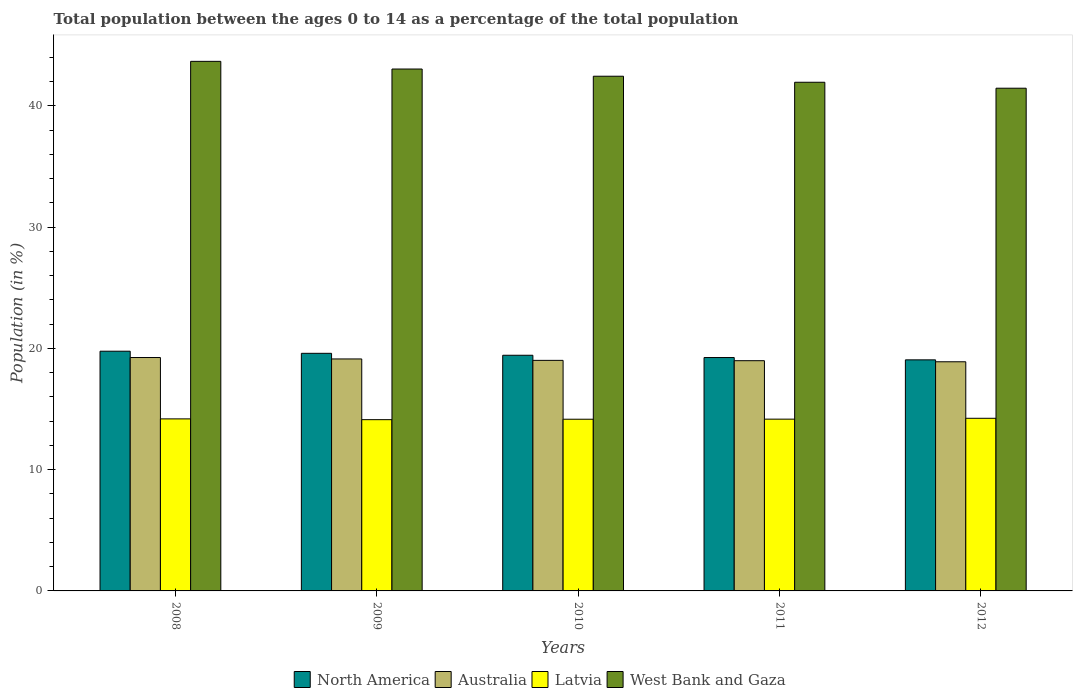How many different coloured bars are there?
Keep it short and to the point. 4. How many groups of bars are there?
Your response must be concise. 5. Are the number of bars per tick equal to the number of legend labels?
Your answer should be compact. Yes. How many bars are there on the 3rd tick from the left?
Give a very brief answer. 4. What is the percentage of the population ages 0 to 14 in Australia in 2012?
Your answer should be compact. 18.89. Across all years, what is the maximum percentage of the population ages 0 to 14 in Latvia?
Give a very brief answer. 14.23. Across all years, what is the minimum percentage of the population ages 0 to 14 in Australia?
Provide a succinct answer. 18.89. In which year was the percentage of the population ages 0 to 14 in North America maximum?
Keep it short and to the point. 2008. In which year was the percentage of the population ages 0 to 14 in Australia minimum?
Keep it short and to the point. 2012. What is the total percentage of the population ages 0 to 14 in Australia in the graph?
Offer a terse response. 95.25. What is the difference between the percentage of the population ages 0 to 14 in Latvia in 2009 and that in 2011?
Offer a terse response. -0.04. What is the difference between the percentage of the population ages 0 to 14 in West Bank and Gaza in 2008 and the percentage of the population ages 0 to 14 in North America in 2009?
Your answer should be compact. 24.07. What is the average percentage of the population ages 0 to 14 in North America per year?
Give a very brief answer. 19.41. In the year 2009, what is the difference between the percentage of the population ages 0 to 14 in North America and percentage of the population ages 0 to 14 in Australia?
Keep it short and to the point. 0.46. What is the ratio of the percentage of the population ages 0 to 14 in North America in 2009 to that in 2012?
Your response must be concise. 1.03. Is the percentage of the population ages 0 to 14 in Australia in 2010 less than that in 2011?
Make the answer very short. No. Is the difference between the percentage of the population ages 0 to 14 in North America in 2011 and 2012 greater than the difference between the percentage of the population ages 0 to 14 in Australia in 2011 and 2012?
Provide a short and direct response. Yes. What is the difference between the highest and the second highest percentage of the population ages 0 to 14 in West Bank and Gaza?
Provide a succinct answer. 0.63. What is the difference between the highest and the lowest percentage of the population ages 0 to 14 in Latvia?
Your answer should be compact. 0.11. Is the sum of the percentage of the population ages 0 to 14 in Latvia in 2011 and 2012 greater than the maximum percentage of the population ages 0 to 14 in West Bank and Gaza across all years?
Provide a short and direct response. No. What does the 4th bar from the left in 2010 represents?
Your answer should be very brief. West Bank and Gaza. What does the 4th bar from the right in 2011 represents?
Offer a very short reply. North America. Is it the case that in every year, the sum of the percentage of the population ages 0 to 14 in Australia and percentage of the population ages 0 to 14 in Latvia is greater than the percentage of the population ages 0 to 14 in West Bank and Gaza?
Offer a terse response. No. How many years are there in the graph?
Offer a very short reply. 5. Where does the legend appear in the graph?
Your answer should be very brief. Bottom center. How many legend labels are there?
Provide a short and direct response. 4. How are the legend labels stacked?
Your response must be concise. Horizontal. What is the title of the graph?
Your answer should be compact. Total population between the ages 0 to 14 as a percentage of the total population. Does "China" appear as one of the legend labels in the graph?
Your answer should be very brief. No. What is the label or title of the X-axis?
Your response must be concise. Years. What is the Population (in %) in North America in 2008?
Your answer should be very brief. 19.76. What is the Population (in %) of Australia in 2008?
Give a very brief answer. 19.24. What is the Population (in %) of Latvia in 2008?
Your response must be concise. 14.18. What is the Population (in %) of West Bank and Gaza in 2008?
Make the answer very short. 43.66. What is the Population (in %) of North America in 2009?
Provide a short and direct response. 19.59. What is the Population (in %) of Australia in 2009?
Give a very brief answer. 19.13. What is the Population (in %) in Latvia in 2009?
Offer a terse response. 14.12. What is the Population (in %) of West Bank and Gaza in 2009?
Make the answer very short. 43.03. What is the Population (in %) of North America in 2010?
Ensure brevity in your answer.  19.43. What is the Population (in %) of Australia in 2010?
Make the answer very short. 19.01. What is the Population (in %) in Latvia in 2010?
Your answer should be compact. 14.15. What is the Population (in %) in West Bank and Gaza in 2010?
Make the answer very short. 42.43. What is the Population (in %) in North America in 2011?
Provide a succinct answer. 19.24. What is the Population (in %) of Australia in 2011?
Your answer should be compact. 18.98. What is the Population (in %) of Latvia in 2011?
Your answer should be compact. 14.16. What is the Population (in %) of West Bank and Gaza in 2011?
Offer a terse response. 41.94. What is the Population (in %) in North America in 2012?
Provide a short and direct response. 19.05. What is the Population (in %) of Australia in 2012?
Ensure brevity in your answer.  18.89. What is the Population (in %) of Latvia in 2012?
Offer a terse response. 14.23. What is the Population (in %) of West Bank and Gaza in 2012?
Ensure brevity in your answer.  41.45. Across all years, what is the maximum Population (in %) in North America?
Offer a very short reply. 19.76. Across all years, what is the maximum Population (in %) in Australia?
Give a very brief answer. 19.24. Across all years, what is the maximum Population (in %) in Latvia?
Keep it short and to the point. 14.23. Across all years, what is the maximum Population (in %) of West Bank and Gaza?
Your answer should be very brief. 43.66. Across all years, what is the minimum Population (in %) in North America?
Your response must be concise. 19.05. Across all years, what is the minimum Population (in %) in Australia?
Offer a very short reply. 18.89. Across all years, what is the minimum Population (in %) of Latvia?
Provide a succinct answer. 14.12. Across all years, what is the minimum Population (in %) in West Bank and Gaza?
Offer a terse response. 41.45. What is the total Population (in %) of North America in the graph?
Make the answer very short. 97.07. What is the total Population (in %) of Australia in the graph?
Your answer should be compact. 95.25. What is the total Population (in %) in Latvia in the graph?
Offer a very short reply. 70.85. What is the total Population (in %) of West Bank and Gaza in the graph?
Your response must be concise. 212.5. What is the difference between the Population (in %) of North America in 2008 and that in 2009?
Your response must be concise. 0.17. What is the difference between the Population (in %) in Australia in 2008 and that in 2009?
Offer a very short reply. 0.12. What is the difference between the Population (in %) in Latvia in 2008 and that in 2009?
Your response must be concise. 0.06. What is the difference between the Population (in %) in West Bank and Gaza in 2008 and that in 2009?
Your answer should be compact. 0.63. What is the difference between the Population (in %) in North America in 2008 and that in 2010?
Offer a terse response. 0.33. What is the difference between the Population (in %) of Australia in 2008 and that in 2010?
Provide a short and direct response. 0.23. What is the difference between the Population (in %) of Latvia in 2008 and that in 2010?
Offer a very short reply. 0.03. What is the difference between the Population (in %) of West Bank and Gaza in 2008 and that in 2010?
Make the answer very short. 1.23. What is the difference between the Population (in %) in North America in 2008 and that in 2011?
Keep it short and to the point. 0.52. What is the difference between the Population (in %) of Australia in 2008 and that in 2011?
Keep it short and to the point. 0.26. What is the difference between the Population (in %) in Latvia in 2008 and that in 2011?
Keep it short and to the point. 0.02. What is the difference between the Population (in %) of West Bank and Gaza in 2008 and that in 2011?
Provide a short and direct response. 1.72. What is the difference between the Population (in %) in North America in 2008 and that in 2012?
Ensure brevity in your answer.  0.71. What is the difference between the Population (in %) of Australia in 2008 and that in 2012?
Keep it short and to the point. 0.35. What is the difference between the Population (in %) in Latvia in 2008 and that in 2012?
Provide a succinct answer. -0.05. What is the difference between the Population (in %) in West Bank and Gaza in 2008 and that in 2012?
Offer a very short reply. 2.21. What is the difference between the Population (in %) in North America in 2009 and that in 2010?
Make the answer very short. 0.16. What is the difference between the Population (in %) in Australia in 2009 and that in 2010?
Provide a succinct answer. 0.12. What is the difference between the Population (in %) in Latvia in 2009 and that in 2010?
Offer a terse response. -0.04. What is the difference between the Population (in %) of West Bank and Gaza in 2009 and that in 2010?
Your answer should be very brief. 0.59. What is the difference between the Population (in %) of North America in 2009 and that in 2011?
Your response must be concise. 0.35. What is the difference between the Population (in %) of Australia in 2009 and that in 2011?
Offer a very short reply. 0.14. What is the difference between the Population (in %) in Latvia in 2009 and that in 2011?
Provide a short and direct response. -0.04. What is the difference between the Population (in %) of West Bank and Gaza in 2009 and that in 2011?
Offer a terse response. 1.09. What is the difference between the Population (in %) of North America in 2009 and that in 2012?
Provide a succinct answer. 0.54. What is the difference between the Population (in %) in Australia in 2009 and that in 2012?
Offer a terse response. 0.23. What is the difference between the Population (in %) in Latvia in 2009 and that in 2012?
Your response must be concise. -0.11. What is the difference between the Population (in %) of West Bank and Gaza in 2009 and that in 2012?
Ensure brevity in your answer.  1.58. What is the difference between the Population (in %) in North America in 2010 and that in 2011?
Make the answer very short. 0.19. What is the difference between the Population (in %) of Australia in 2010 and that in 2011?
Offer a very short reply. 0.03. What is the difference between the Population (in %) of Latvia in 2010 and that in 2011?
Offer a terse response. -0.01. What is the difference between the Population (in %) of West Bank and Gaza in 2010 and that in 2011?
Your response must be concise. 0.5. What is the difference between the Population (in %) of North America in 2010 and that in 2012?
Give a very brief answer. 0.38. What is the difference between the Population (in %) in Australia in 2010 and that in 2012?
Keep it short and to the point. 0.12. What is the difference between the Population (in %) of Latvia in 2010 and that in 2012?
Give a very brief answer. -0.08. What is the difference between the Population (in %) in West Bank and Gaza in 2010 and that in 2012?
Keep it short and to the point. 0.99. What is the difference between the Population (in %) in North America in 2011 and that in 2012?
Offer a terse response. 0.19. What is the difference between the Population (in %) of Australia in 2011 and that in 2012?
Ensure brevity in your answer.  0.09. What is the difference between the Population (in %) of Latvia in 2011 and that in 2012?
Make the answer very short. -0.07. What is the difference between the Population (in %) in West Bank and Gaza in 2011 and that in 2012?
Offer a very short reply. 0.49. What is the difference between the Population (in %) in North America in 2008 and the Population (in %) in Australia in 2009?
Offer a very short reply. 0.64. What is the difference between the Population (in %) of North America in 2008 and the Population (in %) of Latvia in 2009?
Provide a short and direct response. 5.64. What is the difference between the Population (in %) of North America in 2008 and the Population (in %) of West Bank and Gaza in 2009?
Make the answer very short. -23.26. What is the difference between the Population (in %) of Australia in 2008 and the Population (in %) of Latvia in 2009?
Ensure brevity in your answer.  5.12. What is the difference between the Population (in %) in Australia in 2008 and the Population (in %) in West Bank and Gaza in 2009?
Your answer should be very brief. -23.78. What is the difference between the Population (in %) in Latvia in 2008 and the Population (in %) in West Bank and Gaza in 2009?
Provide a succinct answer. -28.84. What is the difference between the Population (in %) in North America in 2008 and the Population (in %) in Australia in 2010?
Your answer should be compact. 0.75. What is the difference between the Population (in %) of North America in 2008 and the Population (in %) of Latvia in 2010?
Make the answer very short. 5.61. What is the difference between the Population (in %) of North America in 2008 and the Population (in %) of West Bank and Gaza in 2010?
Your response must be concise. -22.67. What is the difference between the Population (in %) in Australia in 2008 and the Population (in %) in Latvia in 2010?
Your answer should be compact. 5.09. What is the difference between the Population (in %) of Australia in 2008 and the Population (in %) of West Bank and Gaza in 2010?
Your answer should be very brief. -23.19. What is the difference between the Population (in %) of Latvia in 2008 and the Population (in %) of West Bank and Gaza in 2010?
Make the answer very short. -28.25. What is the difference between the Population (in %) in North America in 2008 and the Population (in %) in Australia in 2011?
Offer a terse response. 0.78. What is the difference between the Population (in %) of North America in 2008 and the Population (in %) of Latvia in 2011?
Provide a succinct answer. 5.6. What is the difference between the Population (in %) of North America in 2008 and the Population (in %) of West Bank and Gaza in 2011?
Ensure brevity in your answer.  -22.17. What is the difference between the Population (in %) in Australia in 2008 and the Population (in %) in Latvia in 2011?
Offer a very short reply. 5.08. What is the difference between the Population (in %) in Australia in 2008 and the Population (in %) in West Bank and Gaza in 2011?
Offer a terse response. -22.69. What is the difference between the Population (in %) of Latvia in 2008 and the Population (in %) of West Bank and Gaza in 2011?
Your answer should be very brief. -27.75. What is the difference between the Population (in %) of North America in 2008 and the Population (in %) of Australia in 2012?
Provide a succinct answer. 0.87. What is the difference between the Population (in %) in North America in 2008 and the Population (in %) in Latvia in 2012?
Provide a short and direct response. 5.53. What is the difference between the Population (in %) in North America in 2008 and the Population (in %) in West Bank and Gaza in 2012?
Your answer should be very brief. -21.68. What is the difference between the Population (in %) in Australia in 2008 and the Population (in %) in Latvia in 2012?
Make the answer very short. 5.01. What is the difference between the Population (in %) of Australia in 2008 and the Population (in %) of West Bank and Gaza in 2012?
Give a very brief answer. -22.2. What is the difference between the Population (in %) of Latvia in 2008 and the Population (in %) of West Bank and Gaza in 2012?
Give a very brief answer. -27.26. What is the difference between the Population (in %) of North America in 2009 and the Population (in %) of Australia in 2010?
Your response must be concise. 0.58. What is the difference between the Population (in %) of North America in 2009 and the Population (in %) of Latvia in 2010?
Your response must be concise. 5.43. What is the difference between the Population (in %) of North America in 2009 and the Population (in %) of West Bank and Gaza in 2010?
Provide a succinct answer. -22.85. What is the difference between the Population (in %) of Australia in 2009 and the Population (in %) of Latvia in 2010?
Provide a short and direct response. 4.97. What is the difference between the Population (in %) in Australia in 2009 and the Population (in %) in West Bank and Gaza in 2010?
Your answer should be compact. -23.31. What is the difference between the Population (in %) in Latvia in 2009 and the Population (in %) in West Bank and Gaza in 2010?
Keep it short and to the point. -28.31. What is the difference between the Population (in %) of North America in 2009 and the Population (in %) of Australia in 2011?
Your response must be concise. 0.61. What is the difference between the Population (in %) in North America in 2009 and the Population (in %) in Latvia in 2011?
Ensure brevity in your answer.  5.43. What is the difference between the Population (in %) of North America in 2009 and the Population (in %) of West Bank and Gaza in 2011?
Give a very brief answer. -22.35. What is the difference between the Population (in %) of Australia in 2009 and the Population (in %) of Latvia in 2011?
Your answer should be very brief. 4.96. What is the difference between the Population (in %) in Australia in 2009 and the Population (in %) in West Bank and Gaza in 2011?
Provide a short and direct response. -22.81. What is the difference between the Population (in %) in Latvia in 2009 and the Population (in %) in West Bank and Gaza in 2011?
Your answer should be compact. -27.82. What is the difference between the Population (in %) in North America in 2009 and the Population (in %) in Australia in 2012?
Ensure brevity in your answer.  0.7. What is the difference between the Population (in %) in North America in 2009 and the Population (in %) in Latvia in 2012?
Give a very brief answer. 5.36. What is the difference between the Population (in %) of North America in 2009 and the Population (in %) of West Bank and Gaza in 2012?
Give a very brief answer. -21.86. What is the difference between the Population (in %) of Australia in 2009 and the Population (in %) of Latvia in 2012?
Offer a very short reply. 4.89. What is the difference between the Population (in %) in Australia in 2009 and the Population (in %) in West Bank and Gaza in 2012?
Give a very brief answer. -22.32. What is the difference between the Population (in %) in Latvia in 2009 and the Population (in %) in West Bank and Gaza in 2012?
Offer a very short reply. -27.33. What is the difference between the Population (in %) in North America in 2010 and the Population (in %) in Australia in 2011?
Provide a short and direct response. 0.45. What is the difference between the Population (in %) in North America in 2010 and the Population (in %) in Latvia in 2011?
Offer a terse response. 5.27. What is the difference between the Population (in %) of North America in 2010 and the Population (in %) of West Bank and Gaza in 2011?
Provide a succinct answer. -22.51. What is the difference between the Population (in %) in Australia in 2010 and the Population (in %) in Latvia in 2011?
Make the answer very short. 4.85. What is the difference between the Population (in %) in Australia in 2010 and the Population (in %) in West Bank and Gaza in 2011?
Give a very brief answer. -22.93. What is the difference between the Population (in %) in Latvia in 2010 and the Population (in %) in West Bank and Gaza in 2011?
Provide a short and direct response. -27.78. What is the difference between the Population (in %) of North America in 2010 and the Population (in %) of Australia in 2012?
Make the answer very short. 0.54. What is the difference between the Population (in %) in North America in 2010 and the Population (in %) in Latvia in 2012?
Ensure brevity in your answer.  5.2. What is the difference between the Population (in %) of North America in 2010 and the Population (in %) of West Bank and Gaza in 2012?
Your answer should be very brief. -22.02. What is the difference between the Population (in %) in Australia in 2010 and the Population (in %) in Latvia in 2012?
Offer a very short reply. 4.78. What is the difference between the Population (in %) in Australia in 2010 and the Population (in %) in West Bank and Gaza in 2012?
Offer a terse response. -22.44. What is the difference between the Population (in %) in Latvia in 2010 and the Population (in %) in West Bank and Gaza in 2012?
Keep it short and to the point. -27.29. What is the difference between the Population (in %) in North America in 2011 and the Population (in %) in Australia in 2012?
Give a very brief answer. 0.35. What is the difference between the Population (in %) in North America in 2011 and the Population (in %) in Latvia in 2012?
Offer a terse response. 5.01. What is the difference between the Population (in %) of North America in 2011 and the Population (in %) of West Bank and Gaza in 2012?
Ensure brevity in your answer.  -22.2. What is the difference between the Population (in %) of Australia in 2011 and the Population (in %) of Latvia in 2012?
Your response must be concise. 4.75. What is the difference between the Population (in %) of Australia in 2011 and the Population (in %) of West Bank and Gaza in 2012?
Your answer should be compact. -22.46. What is the difference between the Population (in %) in Latvia in 2011 and the Population (in %) in West Bank and Gaza in 2012?
Your answer should be compact. -27.28. What is the average Population (in %) of North America per year?
Your response must be concise. 19.41. What is the average Population (in %) in Australia per year?
Offer a very short reply. 19.05. What is the average Population (in %) in Latvia per year?
Your answer should be compact. 14.17. What is the average Population (in %) in West Bank and Gaza per year?
Make the answer very short. 42.5. In the year 2008, what is the difference between the Population (in %) in North America and Population (in %) in Australia?
Offer a terse response. 0.52. In the year 2008, what is the difference between the Population (in %) of North America and Population (in %) of Latvia?
Provide a short and direct response. 5.58. In the year 2008, what is the difference between the Population (in %) in North America and Population (in %) in West Bank and Gaza?
Offer a terse response. -23.9. In the year 2008, what is the difference between the Population (in %) of Australia and Population (in %) of Latvia?
Your response must be concise. 5.06. In the year 2008, what is the difference between the Population (in %) of Australia and Population (in %) of West Bank and Gaza?
Ensure brevity in your answer.  -24.42. In the year 2008, what is the difference between the Population (in %) in Latvia and Population (in %) in West Bank and Gaza?
Offer a terse response. -29.48. In the year 2009, what is the difference between the Population (in %) in North America and Population (in %) in Australia?
Provide a succinct answer. 0.46. In the year 2009, what is the difference between the Population (in %) of North America and Population (in %) of Latvia?
Offer a terse response. 5.47. In the year 2009, what is the difference between the Population (in %) of North America and Population (in %) of West Bank and Gaza?
Your response must be concise. -23.44. In the year 2009, what is the difference between the Population (in %) in Australia and Population (in %) in Latvia?
Keep it short and to the point. 5.01. In the year 2009, what is the difference between the Population (in %) in Australia and Population (in %) in West Bank and Gaza?
Make the answer very short. -23.9. In the year 2009, what is the difference between the Population (in %) of Latvia and Population (in %) of West Bank and Gaza?
Your response must be concise. -28.91. In the year 2010, what is the difference between the Population (in %) of North America and Population (in %) of Australia?
Your answer should be compact. 0.42. In the year 2010, what is the difference between the Population (in %) in North America and Population (in %) in Latvia?
Your answer should be compact. 5.27. In the year 2010, what is the difference between the Population (in %) of North America and Population (in %) of West Bank and Gaza?
Your answer should be very brief. -23.01. In the year 2010, what is the difference between the Population (in %) of Australia and Population (in %) of Latvia?
Your answer should be compact. 4.85. In the year 2010, what is the difference between the Population (in %) in Australia and Population (in %) in West Bank and Gaza?
Provide a short and direct response. -23.43. In the year 2010, what is the difference between the Population (in %) in Latvia and Population (in %) in West Bank and Gaza?
Offer a very short reply. -28.28. In the year 2011, what is the difference between the Population (in %) of North America and Population (in %) of Australia?
Your answer should be compact. 0.26. In the year 2011, what is the difference between the Population (in %) of North America and Population (in %) of Latvia?
Offer a very short reply. 5.08. In the year 2011, what is the difference between the Population (in %) of North America and Population (in %) of West Bank and Gaza?
Offer a very short reply. -22.7. In the year 2011, what is the difference between the Population (in %) in Australia and Population (in %) in Latvia?
Your answer should be compact. 4.82. In the year 2011, what is the difference between the Population (in %) of Australia and Population (in %) of West Bank and Gaza?
Keep it short and to the point. -22.96. In the year 2011, what is the difference between the Population (in %) of Latvia and Population (in %) of West Bank and Gaza?
Provide a succinct answer. -27.77. In the year 2012, what is the difference between the Population (in %) of North America and Population (in %) of Australia?
Your answer should be compact. 0.16. In the year 2012, what is the difference between the Population (in %) in North America and Population (in %) in Latvia?
Provide a short and direct response. 4.82. In the year 2012, what is the difference between the Population (in %) of North America and Population (in %) of West Bank and Gaza?
Offer a terse response. -22.4. In the year 2012, what is the difference between the Population (in %) in Australia and Population (in %) in Latvia?
Make the answer very short. 4.66. In the year 2012, what is the difference between the Population (in %) of Australia and Population (in %) of West Bank and Gaza?
Provide a short and direct response. -22.55. In the year 2012, what is the difference between the Population (in %) in Latvia and Population (in %) in West Bank and Gaza?
Give a very brief answer. -27.21. What is the ratio of the Population (in %) of North America in 2008 to that in 2009?
Keep it short and to the point. 1.01. What is the ratio of the Population (in %) of Australia in 2008 to that in 2009?
Your answer should be very brief. 1.01. What is the ratio of the Population (in %) of Latvia in 2008 to that in 2009?
Give a very brief answer. 1. What is the ratio of the Population (in %) in West Bank and Gaza in 2008 to that in 2009?
Offer a terse response. 1.01. What is the ratio of the Population (in %) of North America in 2008 to that in 2010?
Your answer should be compact. 1.02. What is the ratio of the Population (in %) of Australia in 2008 to that in 2010?
Keep it short and to the point. 1.01. What is the ratio of the Population (in %) of Latvia in 2008 to that in 2010?
Give a very brief answer. 1. What is the ratio of the Population (in %) of West Bank and Gaza in 2008 to that in 2010?
Offer a terse response. 1.03. What is the ratio of the Population (in %) of North America in 2008 to that in 2011?
Ensure brevity in your answer.  1.03. What is the ratio of the Population (in %) in Australia in 2008 to that in 2011?
Ensure brevity in your answer.  1.01. What is the ratio of the Population (in %) of Latvia in 2008 to that in 2011?
Give a very brief answer. 1. What is the ratio of the Population (in %) in West Bank and Gaza in 2008 to that in 2011?
Offer a very short reply. 1.04. What is the ratio of the Population (in %) of North America in 2008 to that in 2012?
Provide a succinct answer. 1.04. What is the ratio of the Population (in %) in Australia in 2008 to that in 2012?
Your answer should be compact. 1.02. What is the ratio of the Population (in %) in West Bank and Gaza in 2008 to that in 2012?
Provide a short and direct response. 1.05. What is the ratio of the Population (in %) of North America in 2009 to that in 2010?
Give a very brief answer. 1.01. What is the ratio of the Population (in %) in West Bank and Gaza in 2009 to that in 2010?
Make the answer very short. 1.01. What is the ratio of the Population (in %) of North America in 2009 to that in 2011?
Your answer should be very brief. 1.02. What is the ratio of the Population (in %) in Australia in 2009 to that in 2011?
Your answer should be compact. 1.01. What is the ratio of the Population (in %) of Latvia in 2009 to that in 2011?
Give a very brief answer. 1. What is the ratio of the Population (in %) in North America in 2009 to that in 2012?
Provide a short and direct response. 1.03. What is the ratio of the Population (in %) in Australia in 2009 to that in 2012?
Ensure brevity in your answer.  1.01. What is the ratio of the Population (in %) of West Bank and Gaza in 2009 to that in 2012?
Your answer should be very brief. 1.04. What is the ratio of the Population (in %) of North America in 2010 to that in 2011?
Provide a short and direct response. 1.01. What is the ratio of the Population (in %) of Australia in 2010 to that in 2011?
Ensure brevity in your answer.  1. What is the ratio of the Population (in %) in West Bank and Gaza in 2010 to that in 2011?
Your answer should be compact. 1.01. What is the ratio of the Population (in %) of North America in 2010 to that in 2012?
Offer a very short reply. 1.02. What is the ratio of the Population (in %) in West Bank and Gaza in 2010 to that in 2012?
Keep it short and to the point. 1.02. What is the ratio of the Population (in %) of North America in 2011 to that in 2012?
Your answer should be compact. 1.01. What is the ratio of the Population (in %) in Australia in 2011 to that in 2012?
Provide a short and direct response. 1. What is the ratio of the Population (in %) in West Bank and Gaza in 2011 to that in 2012?
Offer a very short reply. 1.01. What is the difference between the highest and the second highest Population (in %) in North America?
Your response must be concise. 0.17. What is the difference between the highest and the second highest Population (in %) in Australia?
Ensure brevity in your answer.  0.12. What is the difference between the highest and the second highest Population (in %) of Latvia?
Give a very brief answer. 0.05. What is the difference between the highest and the second highest Population (in %) of West Bank and Gaza?
Your answer should be very brief. 0.63. What is the difference between the highest and the lowest Population (in %) of North America?
Your answer should be compact. 0.71. What is the difference between the highest and the lowest Population (in %) of Australia?
Make the answer very short. 0.35. What is the difference between the highest and the lowest Population (in %) of Latvia?
Provide a succinct answer. 0.11. What is the difference between the highest and the lowest Population (in %) of West Bank and Gaza?
Your response must be concise. 2.21. 